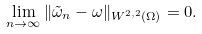<formula> <loc_0><loc_0><loc_500><loc_500>\lim _ { n \to \infty } \| \tilde { \omega } _ { n } - \omega \| _ { W ^ { 2 , 2 } ( \Omega ) } = 0 .</formula> 